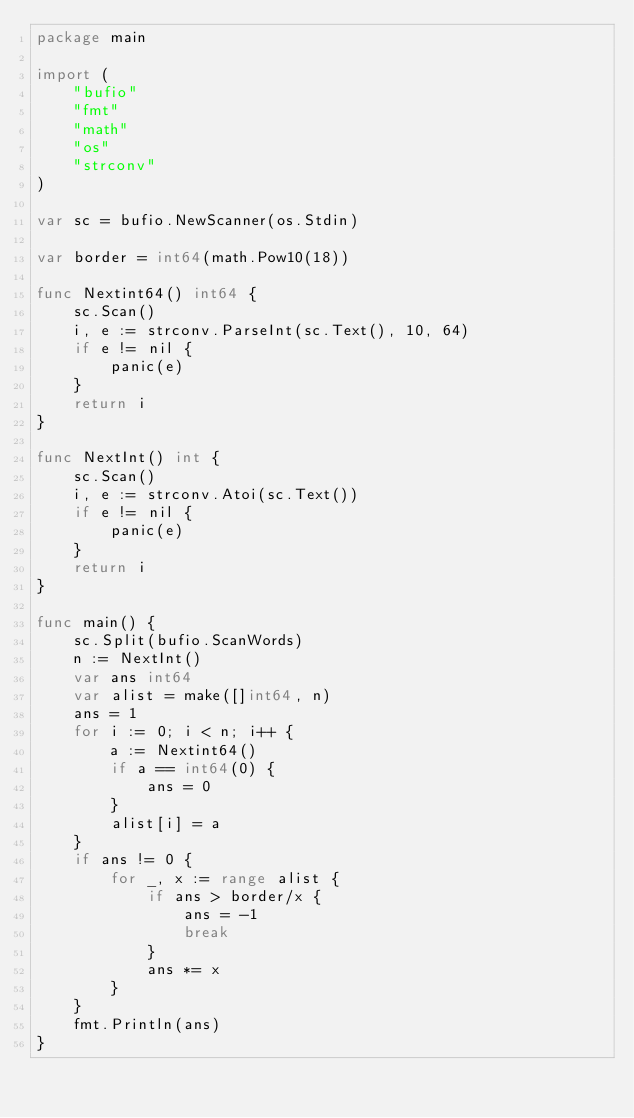<code> <loc_0><loc_0><loc_500><loc_500><_Go_>package main

import (
	"bufio"
	"fmt"
	"math"
	"os"
	"strconv"
)

var sc = bufio.NewScanner(os.Stdin)

var border = int64(math.Pow10(18))

func Nextint64() int64 {
	sc.Scan()
	i, e := strconv.ParseInt(sc.Text(), 10, 64)
	if e != nil {
		panic(e)
	}
	return i
}

func NextInt() int {
	sc.Scan()
	i, e := strconv.Atoi(sc.Text())
	if e != nil {
		panic(e)
	}
	return i
}

func main() {
	sc.Split(bufio.ScanWords)
	n := NextInt()
	var ans int64
	var alist = make([]int64, n)
	ans = 1
	for i := 0; i < n; i++ {
		a := Nextint64()
		if a == int64(0) {
			ans = 0
		}
		alist[i] = a
	}
	if ans != 0 {
		for _, x := range alist {
			if ans > border/x {
				ans = -1
				break
			}
			ans *= x
		}
	}
	fmt.Println(ans)
}
</code> 